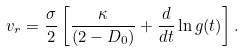Convert formula to latex. <formula><loc_0><loc_0><loc_500><loc_500>v _ { r } = \frac { \sigma } { 2 } \left [ \frac { \kappa } { ( 2 - D _ { 0 } ) } + \frac { d } { d t } \ln { g ( t ) } \right ] .</formula> 